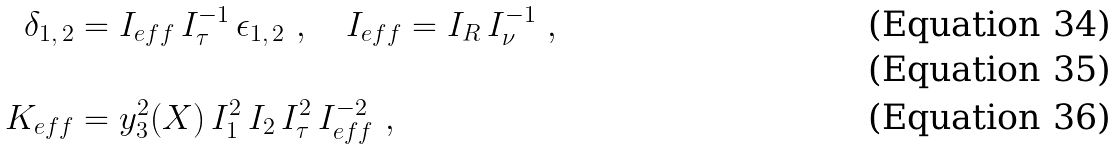<formula> <loc_0><loc_0><loc_500><loc_500>\delta _ { 1 , \, 2 } & = I _ { e f f } \, I ^ { - 1 } _ { \tau } \, \epsilon _ { 1 , \, 2 } \ , \quad I _ { e f f } = I _ { R } \, I _ { \nu } ^ { - 1 } \ , \\ \\ K _ { e f f } & = y _ { 3 } ^ { 2 } ( \L X ) \, I _ { 1 } ^ { 2 } \, I _ { 2 } \, I _ { \tau } ^ { 2 } \, I _ { e f f } ^ { - 2 } \ ,</formula> 